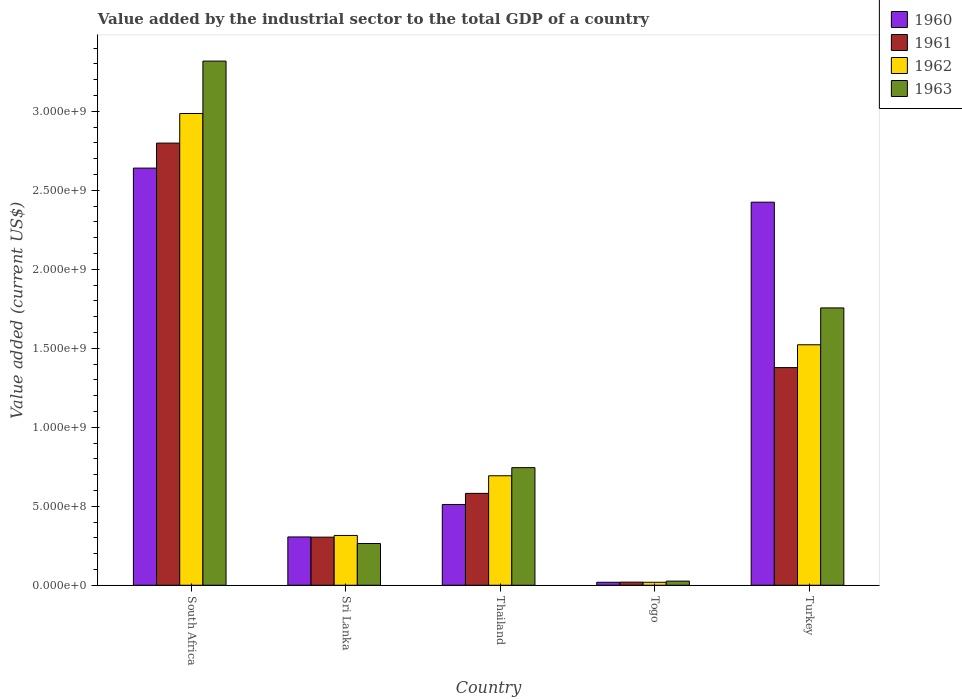Are the number of bars per tick equal to the number of legend labels?
Your answer should be very brief. Yes. Are the number of bars on each tick of the X-axis equal?
Ensure brevity in your answer.  Yes. How many bars are there on the 4th tick from the left?
Keep it short and to the point. 4. What is the label of the 1st group of bars from the left?
Keep it short and to the point. South Africa. What is the value added by the industrial sector to the total GDP in 1961 in Sri Lanka?
Your answer should be very brief. 3.04e+08. Across all countries, what is the maximum value added by the industrial sector to the total GDP in 1963?
Your response must be concise. 3.32e+09. Across all countries, what is the minimum value added by the industrial sector to the total GDP in 1963?
Make the answer very short. 2.61e+07. In which country was the value added by the industrial sector to the total GDP in 1961 maximum?
Your response must be concise. South Africa. In which country was the value added by the industrial sector to the total GDP in 1962 minimum?
Make the answer very short. Togo. What is the total value added by the industrial sector to the total GDP in 1962 in the graph?
Offer a terse response. 5.54e+09. What is the difference between the value added by the industrial sector to the total GDP in 1963 in South Africa and that in Turkey?
Your answer should be compact. 1.56e+09. What is the difference between the value added by the industrial sector to the total GDP in 1960 in Togo and the value added by the industrial sector to the total GDP in 1963 in South Africa?
Your answer should be compact. -3.30e+09. What is the average value added by the industrial sector to the total GDP in 1960 per country?
Provide a succinct answer. 1.18e+09. What is the difference between the value added by the industrial sector to the total GDP of/in 1962 and value added by the industrial sector to the total GDP of/in 1963 in South Africa?
Ensure brevity in your answer.  -3.32e+08. What is the ratio of the value added by the industrial sector to the total GDP in 1960 in South Africa to that in Togo?
Ensure brevity in your answer.  140.76. Is the value added by the industrial sector to the total GDP in 1961 in Togo less than that in Turkey?
Your answer should be compact. Yes. What is the difference between the highest and the second highest value added by the industrial sector to the total GDP in 1960?
Your answer should be very brief. 2.13e+09. What is the difference between the highest and the lowest value added by the industrial sector to the total GDP in 1960?
Provide a short and direct response. 2.62e+09. Is it the case that in every country, the sum of the value added by the industrial sector to the total GDP in 1961 and value added by the industrial sector to the total GDP in 1963 is greater than the value added by the industrial sector to the total GDP in 1960?
Offer a very short reply. Yes. How many bars are there?
Your answer should be very brief. 20. Are all the bars in the graph horizontal?
Your answer should be compact. No. How many countries are there in the graph?
Offer a very short reply. 5. Are the values on the major ticks of Y-axis written in scientific E-notation?
Provide a short and direct response. Yes. Does the graph contain any zero values?
Your response must be concise. No. Does the graph contain grids?
Make the answer very short. No. How many legend labels are there?
Your response must be concise. 4. What is the title of the graph?
Give a very brief answer. Value added by the industrial sector to the total GDP of a country. Does "1961" appear as one of the legend labels in the graph?
Your answer should be compact. Yes. What is the label or title of the Y-axis?
Your answer should be compact. Value added (current US$). What is the Value added (current US$) in 1960 in South Africa?
Offer a very short reply. 2.64e+09. What is the Value added (current US$) in 1961 in South Africa?
Ensure brevity in your answer.  2.80e+09. What is the Value added (current US$) in 1962 in South Africa?
Your answer should be compact. 2.99e+09. What is the Value added (current US$) in 1963 in South Africa?
Offer a very short reply. 3.32e+09. What is the Value added (current US$) of 1960 in Sri Lanka?
Your answer should be compact. 3.06e+08. What is the Value added (current US$) of 1961 in Sri Lanka?
Give a very brief answer. 3.04e+08. What is the Value added (current US$) in 1962 in Sri Lanka?
Your response must be concise. 3.15e+08. What is the Value added (current US$) in 1963 in Sri Lanka?
Keep it short and to the point. 2.64e+08. What is the Value added (current US$) of 1960 in Thailand?
Offer a terse response. 5.11e+08. What is the Value added (current US$) in 1961 in Thailand?
Your answer should be very brief. 5.81e+08. What is the Value added (current US$) of 1962 in Thailand?
Offer a terse response. 6.93e+08. What is the Value added (current US$) of 1963 in Thailand?
Give a very brief answer. 7.44e+08. What is the Value added (current US$) in 1960 in Togo?
Offer a very short reply. 1.88e+07. What is the Value added (current US$) in 1961 in Togo?
Keep it short and to the point. 1.96e+07. What is the Value added (current US$) of 1962 in Togo?
Your answer should be very brief. 1.88e+07. What is the Value added (current US$) of 1963 in Togo?
Your answer should be compact. 2.61e+07. What is the Value added (current US$) in 1960 in Turkey?
Your answer should be compact. 2.42e+09. What is the Value added (current US$) in 1961 in Turkey?
Offer a terse response. 1.38e+09. What is the Value added (current US$) in 1962 in Turkey?
Provide a succinct answer. 1.52e+09. What is the Value added (current US$) of 1963 in Turkey?
Ensure brevity in your answer.  1.76e+09. Across all countries, what is the maximum Value added (current US$) in 1960?
Offer a terse response. 2.64e+09. Across all countries, what is the maximum Value added (current US$) of 1961?
Your answer should be very brief. 2.80e+09. Across all countries, what is the maximum Value added (current US$) of 1962?
Keep it short and to the point. 2.99e+09. Across all countries, what is the maximum Value added (current US$) of 1963?
Provide a succinct answer. 3.32e+09. Across all countries, what is the minimum Value added (current US$) in 1960?
Your response must be concise. 1.88e+07. Across all countries, what is the minimum Value added (current US$) of 1961?
Your answer should be compact. 1.96e+07. Across all countries, what is the minimum Value added (current US$) of 1962?
Provide a succinct answer. 1.88e+07. Across all countries, what is the minimum Value added (current US$) in 1963?
Provide a short and direct response. 2.61e+07. What is the total Value added (current US$) of 1960 in the graph?
Keep it short and to the point. 5.90e+09. What is the total Value added (current US$) in 1961 in the graph?
Make the answer very short. 5.08e+09. What is the total Value added (current US$) of 1962 in the graph?
Offer a very short reply. 5.54e+09. What is the total Value added (current US$) of 1963 in the graph?
Make the answer very short. 6.11e+09. What is the difference between the Value added (current US$) of 1960 in South Africa and that in Sri Lanka?
Your answer should be very brief. 2.33e+09. What is the difference between the Value added (current US$) of 1961 in South Africa and that in Sri Lanka?
Ensure brevity in your answer.  2.49e+09. What is the difference between the Value added (current US$) of 1962 in South Africa and that in Sri Lanka?
Offer a very short reply. 2.67e+09. What is the difference between the Value added (current US$) in 1963 in South Africa and that in Sri Lanka?
Your response must be concise. 3.05e+09. What is the difference between the Value added (current US$) of 1960 in South Africa and that in Thailand?
Provide a short and direct response. 2.13e+09. What is the difference between the Value added (current US$) in 1961 in South Africa and that in Thailand?
Give a very brief answer. 2.22e+09. What is the difference between the Value added (current US$) in 1962 in South Africa and that in Thailand?
Make the answer very short. 2.29e+09. What is the difference between the Value added (current US$) of 1963 in South Africa and that in Thailand?
Keep it short and to the point. 2.57e+09. What is the difference between the Value added (current US$) in 1960 in South Africa and that in Togo?
Your response must be concise. 2.62e+09. What is the difference between the Value added (current US$) in 1961 in South Africa and that in Togo?
Offer a very short reply. 2.78e+09. What is the difference between the Value added (current US$) of 1962 in South Africa and that in Togo?
Offer a very short reply. 2.97e+09. What is the difference between the Value added (current US$) of 1963 in South Africa and that in Togo?
Ensure brevity in your answer.  3.29e+09. What is the difference between the Value added (current US$) in 1960 in South Africa and that in Turkey?
Your answer should be compact. 2.16e+08. What is the difference between the Value added (current US$) of 1961 in South Africa and that in Turkey?
Keep it short and to the point. 1.42e+09. What is the difference between the Value added (current US$) of 1962 in South Africa and that in Turkey?
Your answer should be very brief. 1.46e+09. What is the difference between the Value added (current US$) of 1963 in South Africa and that in Turkey?
Provide a short and direct response. 1.56e+09. What is the difference between the Value added (current US$) of 1960 in Sri Lanka and that in Thailand?
Keep it short and to the point. -2.06e+08. What is the difference between the Value added (current US$) of 1961 in Sri Lanka and that in Thailand?
Make the answer very short. -2.77e+08. What is the difference between the Value added (current US$) of 1962 in Sri Lanka and that in Thailand?
Give a very brief answer. -3.78e+08. What is the difference between the Value added (current US$) in 1963 in Sri Lanka and that in Thailand?
Make the answer very short. -4.80e+08. What is the difference between the Value added (current US$) of 1960 in Sri Lanka and that in Togo?
Provide a short and direct response. 2.87e+08. What is the difference between the Value added (current US$) in 1961 in Sri Lanka and that in Togo?
Keep it short and to the point. 2.85e+08. What is the difference between the Value added (current US$) in 1962 in Sri Lanka and that in Togo?
Provide a succinct answer. 2.96e+08. What is the difference between the Value added (current US$) of 1963 in Sri Lanka and that in Togo?
Provide a short and direct response. 2.38e+08. What is the difference between the Value added (current US$) of 1960 in Sri Lanka and that in Turkey?
Make the answer very short. -2.12e+09. What is the difference between the Value added (current US$) in 1961 in Sri Lanka and that in Turkey?
Ensure brevity in your answer.  -1.07e+09. What is the difference between the Value added (current US$) in 1962 in Sri Lanka and that in Turkey?
Your answer should be compact. -1.21e+09. What is the difference between the Value added (current US$) in 1963 in Sri Lanka and that in Turkey?
Your response must be concise. -1.49e+09. What is the difference between the Value added (current US$) in 1960 in Thailand and that in Togo?
Your answer should be very brief. 4.92e+08. What is the difference between the Value added (current US$) in 1961 in Thailand and that in Togo?
Provide a succinct answer. 5.62e+08. What is the difference between the Value added (current US$) of 1962 in Thailand and that in Togo?
Provide a succinct answer. 6.74e+08. What is the difference between the Value added (current US$) of 1963 in Thailand and that in Togo?
Keep it short and to the point. 7.18e+08. What is the difference between the Value added (current US$) of 1960 in Thailand and that in Turkey?
Provide a short and direct response. -1.91e+09. What is the difference between the Value added (current US$) of 1961 in Thailand and that in Turkey?
Keep it short and to the point. -7.96e+08. What is the difference between the Value added (current US$) of 1962 in Thailand and that in Turkey?
Your answer should be compact. -8.29e+08. What is the difference between the Value added (current US$) of 1963 in Thailand and that in Turkey?
Provide a short and direct response. -1.01e+09. What is the difference between the Value added (current US$) of 1960 in Togo and that in Turkey?
Give a very brief answer. -2.41e+09. What is the difference between the Value added (current US$) in 1961 in Togo and that in Turkey?
Provide a short and direct response. -1.36e+09. What is the difference between the Value added (current US$) of 1962 in Togo and that in Turkey?
Provide a short and direct response. -1.50e+09. What is the difference between the Value added (current US$) in 1963 in Togo and that in Turkey?
Ensure brevity in your answer.  -1.73e+09. What is the difference between the Value added (current US$) in 1960 in South Africa and the Value added (current US$) in 1961 in Sri Lanka?
Offer a terse response. 2.34e+09. What is the difference between the Value added (current US$) of 1960 in South Africa and the Value added (current US$) of 1962 in Sri Lanka?
Offer a terse response. 2.33e+09. What is the difference between the Value added (current US$) of 1960 in South Africa and the Value added (current US$) of 1963 in Sri Lanka?
Provide a succinct answer. 2.38e+09. What is the difference between the Value added (current US$) of 1961 in South Africa and the Value added (current US$) of 1962 in Sri Lanka?
Provide a succinct answer. 2.48e+09. What is the difference between the Value added (current US$) of 1961 in South Africa and the Value added (current US$) of 1963 in Sri Lanka?
Your response must be concise. 2.53e+09. What is the difference between the Value added (current US$) in 1962 in South Africa and the Value added (current US$) in 1963 in Sri Lanka?
Your answer should be very brief. 2.72e+09. What is the difference between the Value added (current US$) of 1960 in South Africa and the Value added (current US$) of 1961 in Thailand?
Ensure brevity in your answer.  2.06e+09. What is the difference between the Value added (current US$) in 1960 in South Africa and the Value added (current US$) in 1962 in Thailand?
Your answer should be very brief. 1.95e+09. What is the difference between the Value added (current US$) of 1960 in South Africa and the Value added (current US$) of 1963 in Thailand?
Keep it short and to the point. 1.90e+09. What is the difference between the Value added (current US$) in 1961 in South Africa and the Value added (current US$) in 1962 in Thailand?
Your response must be concise. 2.11e+09. What is the difference between the Value added (current US$) in 1961 in South Africa and the Value added (current US$) in 1963 in Thailand?
Make the answer very short. 2.05e+09. What is the difference between the Value added (current US$) of 1962 in South Africa and the Value added (current US$) of 1963 in Thailand?
Offer a terse response. 2.24e+09. What is the difference between the Value added (current US$) of 1960 in South Africa and the Value added (current US$) of 1961 in Togo?
Make the answer very short. 2.62e+09. What is the difference between the Value added (current US$) of 1960 in South Africa and the Value added (current US$) of 1962 in Togo?
Offer a very short reply. 2.62e+09. What is the difference between the Value added (current US$) in 1960 in South Africa and the Value added (current US$) in 1963 in Togo?
Your answer should be very brief. 2.61e+09. What is the difference between the Value added (current US$) in 1961 in South Africa and the Value added (current US$) in 1962 in Togo?
Offer a very short reply. 2.78e+09. What is the difference between the Value added (current US$) in 1961 in South Africa and the Value added (current US$) in 1963 in Togo?
Offer a very short reply. 2.77e+09. What is the difference between the Value added (current US$) of 1962 in South Africa and the Value added (current US$) of 1963 in Togo?
Offer a terse response. 2.96e+09. What is the difference between the Value added (current US$) in 1960 in South Africa and the Value added (current US$) in 1961 in Turkey?
Your answer should be compact. 1.26e+09. What is the difference between the Value added (current US$) of 1960 in South Africa and the Value added (current US$) of 1962 in Turkey?
Keep it short and to the point. 1.12e+09. What is the difference between the Value added (current US$) in 1960 in South Africa and the Value added (current US$) in 1963 in Turkey?
Keep it short and to the point. 8.85e+08. What is the difference between the Value added (current US$) of 1961 in South Africa and the Value added (current US$) of 1962 in Turkey?
Provide a short and direct response. 1.28e+09. What is the difference between the Value added (current US$) of 1961 in South Africa and the Value added (current US$) of 1963 in Turkey?
Provide a short and direct response. 1.04e+09. What is the difference between the Value added (current US$) of 1962 in South Africa and the Value added (current US$) of 1963 in Turkey?
Offer a very short reply. 1.23e+09. What is the difference between the Value added (current US$) in 1960 in Sri Lanka and the Value added (current US$) in 1961 in Thailand?
Offer a terse response. -2.76e+08. What is the difference between the Value added (current US$) of 1960 in Sri Lanka and the Value added (current US$) of 1962 in Thailand?
Provide a succinct answer. -3.87e+08. What is the difference between the Value added (current US$) in 1960 in Sri Lanka and the Value added (current US$) in 1963 in Thailand?
Your response must be concise. -4.39e+08. What is the difference between the Value added (current US$) of 1961 in Sri Lanka and the Value added (current US$) of 1962 in Thailand?
Offer a terse response. -3.89e+08. What is the difference between the Value added (current US$) in 1961 in Sri Lanka and the Value added (current US$) in 1963 in Thailand?
Make the answer very short. -4.40e+08. What is the difference between the Value added (current US$) of 1962 in Sri Lanka and the Value added (current US$) of 1963 in Thailand?
Keep it short and to the point. -4.29e+08. What is the difference between the Value added (current US$) of 1960 in Sri Lanka and the Value added (current US$) of 1961 in Togo?
Your response must be concise. 2.86e+08. What is the difference between the Value added (current US$) in 1960 in Sri Lanka and the Value added (current US$) in 1962 in Togo?
Your response must be concise. 2.87e+08. What is the difference between the Value added (current US$) of 1960 in Sri Lanka and the Value added (current US$) of 1963 in Togo?
Your answer should be compact. 2.80e+08. What is the difference between the Value added (current US$) in 1961 in Sri Lanka and the Value added (current US$) in 1962 in Togo?
Give a very brief answer. 2.86e+08. What is the difference between the Value added (current US$) of 1961 in Sri Lanka and the Value added (current US$) of 1963 in Togo?
Offer a very short reply. 2.78e+08. What is the difference between the Value added (current US$) in 1962 in Sri Lanka and the Value added (current US$) in 1963 in Togo?
Offer a very short reply. 2.89e+08. What is the difference between the Value added (current US$) in 1960 in Sri Lanka and the Value added (current US$) in 1961 in Turkey?
Keep it short and to the point. -1.07e+09. What is the difference between the Value added (current US$) in 1960 in Sri Lanka and the Value added (current US$) in 1962 in Turkey?
Provide a succinct answer. -1.22e+09. What is the difference between the Value added (current US$) in 1960 in Sri Lanka and the Value added (current US$) in 1963 in Turkey?
Give a very brief answer. -1.45e+09. What is the difference between the Value added (current US$) in 1961 in Sri Lanka and the Value added (current US$) in 1962 in Turkey?
Your answer should be very brief. -1.22e+09. What is the difference between the Value added (current US$) in 1961 in Sri Lanka and the Value added (current US$) in 1963 in Turkey?
Your answer should be very brief. -1.45e+09. What is the difference between the Value added (current US$) of 1962 in Sri Lanka and the Value added (current US$) of 1963 in Turkey?
Provide a succinct answer. -1.44e+09. What is the difference between the Value added (current US$) of 1960 in Thailand and the Value added (current US$) of 1961 in Togo?
Keep it short and to the point. 4.92e+08. What is the difference between the Value added (current US$) in 1960 in Thailand and the Value added (current US$) in 1962 in Togo?
Keep it short and to the point. 4.92e+08. What is the difference between the Value added (current US$) of 1960 in Thailand and the Value added (current US$) of 1963 in Togo?
Offer a terse response. 4.85e+08. What is the difference between the Value added (current US$) of 1961 in Thailand and the Value added (current US$) of 1962 in Togo?
Offer a very short reply. 5.63e+08. What is the difference between the Value added (current US$) of 1961 in Thailand and the Value added (current US$) of 1963 in Togo?
Make the answer very short. 5.55e+08. What is the difference between the Value added (current US$) in 1962 in Thailand and the Value added (current US$) in 1963 in Togo?
Provide a short and direct response. 6.67e+08. What is the difference between the Value added (current US$) of 1960 in Thailand and the Value added (current US$) of 1961 in Turkey?
Ensure brevity in your answer.  -8.67e+08. What is the difference between the Value added (current US$) in 1960 in Thailand and the Value added (current US$) in 1962 in Turkey?
Provide a succinct answer. -1.01e+09. What is the difference between the Value added (current US$) of 1960 in Thailand and the Value added (current US$) of 1963 in Turkey?
Give a very brief answer. -1.24e+09. What is the difference between the Value added (current US$) of 1961 in Thailand and the Value added (current US$) of 1962 in Turkey?
Provide a short and direct response. -9.41e+08. What is the difference between the Value added (current US$) of 1961 in Thailand and the Value added (current US$) of 1963 in Turkey?
Your response must be concise. -1.17e+09. What is the difference between the Value added (current US$) in 1962 in Thailand and the Value added (current US$) in 1963 in Turkey?
Provide a short and direct response. -1.06e+09. What is the difference between the Value added (current US$) in 1960 in Togo and the Value added (current US$) in 1961 in Turkey?
Your response must be concise. -1.36e+09. What is the difference between the Value added (current US$) in 1960 in Togo and the Value added (current US$) in 1962 in Turkey?
Ensure brevity in your answer.  -1.50e+09. What is the difference between the Value added (current US$) in 1960 in Togo and the Value added (current US$) in 1963 in Turkey?
Offer a terse response. -1.74e+09. What is the difference between the Value added (current US$) of 1961 in Togo and the Value added (current US$) of 1962 in Turkey?
Your response must be concise. -1.50e+09. What is the difference between the Value added (current US$) of 1961 in Togo and the Value added (current US$) of 1963 in Turkey?
Keep it short and to the point. -1.74e+09. What is the difference between the Value added (current US$) in 1962 in Togo and the Value added (current US$) in 1963 in Turkey?
Your answer should be compact. -1.74e+09. What is the average Value added (current US$) in 1960 per country?
Your answer should be very brief. 1.18e+09. What is the average Value added (current US$) of 1961 per country?
Offer a terse response. 1.02e+09. What is the average Value added (current US$) of 1962 per country?
Offer a terse response. 1.11e+09. What is the average Value added (current US$) in 1963 per country?
Provide a short and direct response. 1.22e+09. What is the difference between the Value added (current US$) of 1960 and Value added (current US$) of 1961 in South Africa?
Provide a short and direct response. -1.58e+08. What is the difference between the Value added (current US$) of 1960 and Value added (current US$) of 1962 in South Africa?
Keep it short and to the point. -3.46e+08. What is the difference between the Value added (current US$) in 1960 and Value added (current US$) in 1963 in South Africa?
Provide a succinct answer. -6.78e+08. What is the difference between the Value added (current US$) in 1961 and Value added (current US$) in 1962 in South Africa?
Keep it short and to the point. -1.87e+08. What is the difference between the Value added (current US$) of 1961 and Value added (current US$) of 1963 in South Africa?
Offer a terse response. -5.19e+08. What is the difference between the Value added (current US$) in 1962 and Value added (current US$) in 1963 in South Africa?
Offer a terse response. -3.32e+08. What is the difference between the Value added (current US$) in 1960 and Value added (current US$) in 1961 in Sri Lanka?
Make the answer very short. 1.26e+06. What is the difference between the Value added (current US$) in 1960 and Value added (current US$) in 1962 in Sri Lanka?
Offer a very short reply. -9.55e+06. What is the difference between the Value added (current US$) of 1960 and Value added (current US$) of 1963 in Sri Lanka?
Your response must be concise. 4.16e+07. What is the difference between the Value added (current US$) of 1961 and Value added (current US$) of 1962 in Sri Lanka?
Make the answer very short. -1.08e+07. What is the difference between the Value added (current US$) in 1961 and Value added (current US$) in 1963 in Sri Lanka?
Your response must be concise. 4.04e+07. What is the difference between the Value added (current US$) in 1962 and Value added (current US$) in 1963 in Sri Lanka?
Provide a succinct answer. 5.12e+07. What is the difference between the Value added (current US$) in 1960 and Value added (current US$) in 1961 in Thailand?
Your response must be concise. -7.03e+07. What is the difference between the Value added (current US$) of 1960 and Value added (current US$) of 1962 in Thailand?
Give a very brief answer. -1.82e+08. What is the difference between the Value added (current US$) of 1960 and Value added (current US$) of 1963 in Thailand?
Give a very brief answer. -2.33e+08. What is the difference between the Value added (current US$) in 1961 and Value added (current US$) in 1962 in Thailand?
Your answer should be compact. -1.12e+08. What is the difference between the Value added (current US$) in 1961 and Value added (current US$) in 1963 in Thailand?
Offer a very short reply. -1.63e+08. What is the difference between the Value added (current US$) of 1962 and Value added (current US$) of 1963 in Thailand?
Provide a short and direct response. -5.15e+07. What is the difference between the Value added (current US$) in 1960 and Value added (current US$) in 1961 in Togo?
Your answer should be compact. -8.10e+05. What is the difference between the Value added (current US$) of 1960 and Value added (current US$) of 1962 in Togo?
Give a very brief answer. -1.39e+04. What is the difference between the Value added (current US$) in 1960 and Value added (current US$) in 1963 in Togo?
Make the answer very short. -7.36e+06. What is the difference between the Value added (current US$) of 1961 and Value added (current US$) of 1962 in Togo?
Make the answer very short. 7.97e+05. What is the difference between the Value added (current US$) in 1961 and Value added (current US$) in 1963 in Togo?
Your answer should be compact. -6.55e+06. What is the difference between the Value added (current US$) of 1962 and Value added (current US$) of 1963 in Togo?
Your answer should be compact. -7.35e+06. What is the difference between the Value added (current US$) in 1960 and Value added (current US$) in 1961 in Turkey?
Provide a succinct answer. 1.05e+09. What is the difference between the Value added (current US$) of 1960 and Value added (current US$) of 1962 in Turkey?
Offer a terse response. 9.03e+08. What is the difference between the Value added (current US$) of 1960 and Value added (current US$) of 1963 in Turkey?
Keep it short and to the point. 6.69e+08. What is the difference between the Value added (current US$) of 1961 and Value added (current US$) of 1962 in Turkey?
Offer a very short reply. -1.44e+08. What is the difference between the Value added (current US$) in 1961 and Value added (current US$) in 1963 in Turkey?
Offer a terse response. -3.78e+08. What is the difference between the Value added (current US$) of 1962 and Value added (current US$) of 1963 in Turkey?
Make the answer very short. -2.33e+08. What is the ratio of the Value added (current US$) of 1960 in South Africa to that in Sri Lanka?
Give a very brief answer. 8.64. What is the ratio of the Value added (current US$) of 1961 in South Africa to that in Sri Lanka?
Make the answer very short. 9.19. What is the ratio of the Value added (current US$) in 1962 in South Africa to that in Sri Lanka?
Give a very brief answer. 9.47. What is the ratio of the Value added (current US$) of 1963 in South Africa to that in Sri Lanka?
Keep it short and to the point. 12.57. What is the ratio of the Value added (current US$) of 1960 in South Africa to that in Thailand?
Ensure brevity in your answer.  5.17. What is the ratio of the Value added (current US$) in 1961 in South Africa to that in Thailand?
Ensure brevity in your answer.  4.81. What is the ratio of the Value added (current US$) of 1962 in South Africa to that in Thailand?
Provide a succinct answer. 4.31. What is the ratio of the Value added (current US$) in 1963 in South Africa to that in Thailand?
Offer a terse response. 4.46. What is the ratio of the Value added (current US$) in 1960 in South Africa to that in Togo?
Provide a short and direct response. 140.76. What is the ratio of the Value added (current US$) in 1961 in South Africa to that in Togo?
Give a very brief answer. 143.01. What is the ratio of the Value added (current US$) of 1962 in South Africa to that in Togo?
Make the answer very short. 159.06. What is the ratio of the Value added (current US$) of 1963 in South Africa to that in Togo?
Give a very brief answer. 127.03. What is the ratio of the Value added (current US$) of 1960 in South Africa to that in Turkey?
Give a very brief answer. 1.09. What is the ratio of the Value added (current US$) of 1961 in South Africa to that in Turkey?
Your answer should be very brief. 2.03. What is the ratio of the Value added (current US$) of 1962 in South Africa to that in Turkey?
Provide a short and direct response. 1.96. What is the ratio of the Value added (current US$) of 1963 in South Africa to that in Turkey?
Your answer should be very brief. 1.89. What is the ratio of the Value added (current US$) of 1960 in Sri Lanka to that in Thailand?
Provide a short and direct response. 0.6. What is the ratio of the Value added (current US$) of 1961 in Sri Lanka to that in Thailand?
Provide a succinct answer. 0.52. What is the ratio of the Value added (current US$) in 1962 in Sri Lanka to that in Thailand?
Your answer should be very brief. 0.45. What is the ratio of the Value added (current US$) in 1963 in Sri Lanka to that in Thailand?
Your response must be concise. 0.35. What is the ratio of the Value added (current US$) of 1960 in Sri Lanka to that in Togo?
Provide a short and direct response. 16.29. What is the ratio of the Value added (current US$) of 1961 in Sri Lanka to that in Togo?
Offer a very short reply. 15.55. What is the ratio of the Value added (current US$) in 1962 in Sri Lanka to that in Togo?
Provide a short and direct response. 16.79. What is the ratio of the Value added (current US$) in 1963 in Sri Lanka to that in Togo?
Your answer should be very brief. 10.11. What is the ratio of the Value added (current US$) of 1960 in Sri Lanka to that in Turkey?
Your answer should be very brief. 0.13. What is the ratio of the Value added (current US$) of 1961 in Sri Lanka to that in Turkey?
Provide a short and direct response. 0.22. What is the ratio of the Value added (current US$) in 1962 in Sri Lanka to that in Turkey?
Make the answer very short. 0.21. What is the ratio of the Value added (current US$) in 1963 in Sri Lanka to that in Turkey?
Ensure brevity in your answer.  0.15. What is the ratio of the Value added (current US$) of 1960 in Thailand to that in Togo?
Give a very brief answer. 27.25. What is the ratio of the Value added (current US$) of 1961 in Thailand to that in Togo?
Give a very brief answer. 29.71. What is the ratio of the Value added (current US$) of 1962 in Thailand to that in Togo?
Ensure brevity in your answer.  36.91. What is the ratio of the Value added (current US$) in 1960 in Thailand to that in Turkey?
Your answer should be very brief. 0.21. What is the ratio of the Value added (current US$) in 1961 in Thailand to that in Turkey?
Offer a very short reply. 0.42. What is the ratio of the Value added (current US$) of 1962 in Thailand to that in Turkey?
Offer a terse response. 0.46. What is the ratio of the Value added (current US$) of 1963 in Thailand to that in Turkey?
Offer a very short reply. 0.42. What is the ratio of the Value added (current US$) of 1960 in Togo to that in Turkey?
Offer a very short reply. 0.01. What is the ratio of the Value added (current US$) in 1961 in Togo to that in Turkey?
Provide a succinct answer. 0.01. What is the ratio of the Value added (current US$) of 1962 in Togo to that in Turkey?
Your answer should be compact. 0.01. What is the ratio of the Value added (current US$) in 1963 in Togo to that in Turkey?
Provide a succinct answer. 0.01. What is the difference between the highest and the second highest Value added (current US$) in 1960?
Your response must be concise. 2.16e+08. What is the difference between the highest and the second highest Value added (current US$) of 1961?
Offer a terse response. 1.42e+09. What is the difference between the highest and the second highest Value added (current US$) in 1962?
Ensure brevity in your answer.  1.46e+09. What is the difference between the highest and the second highest Value added (current US$) of 1963?
Give a very brief answer. 1.56e+09. What is the difference between the highest and the lowest Value added (current US$) of 1960?
Your response must be concise. 2.62e+09. What is the difference between the highest and the lowest Value added (current US$) of 1961?
Your answer should be compact. 2.78e+09. What is the difference between the highest and the lowest Value added (current US$) of 1962?
Keep it short and to the point. 2.97e+09. What is the difference between the highest and the lowest Value added (current US$) of 1963?
Ensure brevity in your answer.  3.29e+09. 